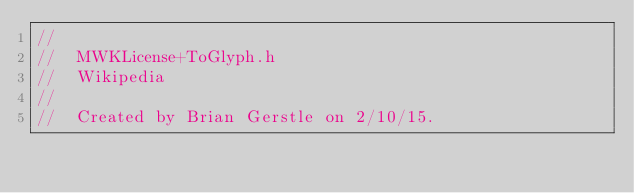<code> <loc_0><loc_0><loc_500><loc_500><_C_>//
//  MWKLicense+ToGlyph.h
//  Wikipedia
//
//  Created by Brian Gerstle on 2/10/15.</code> 